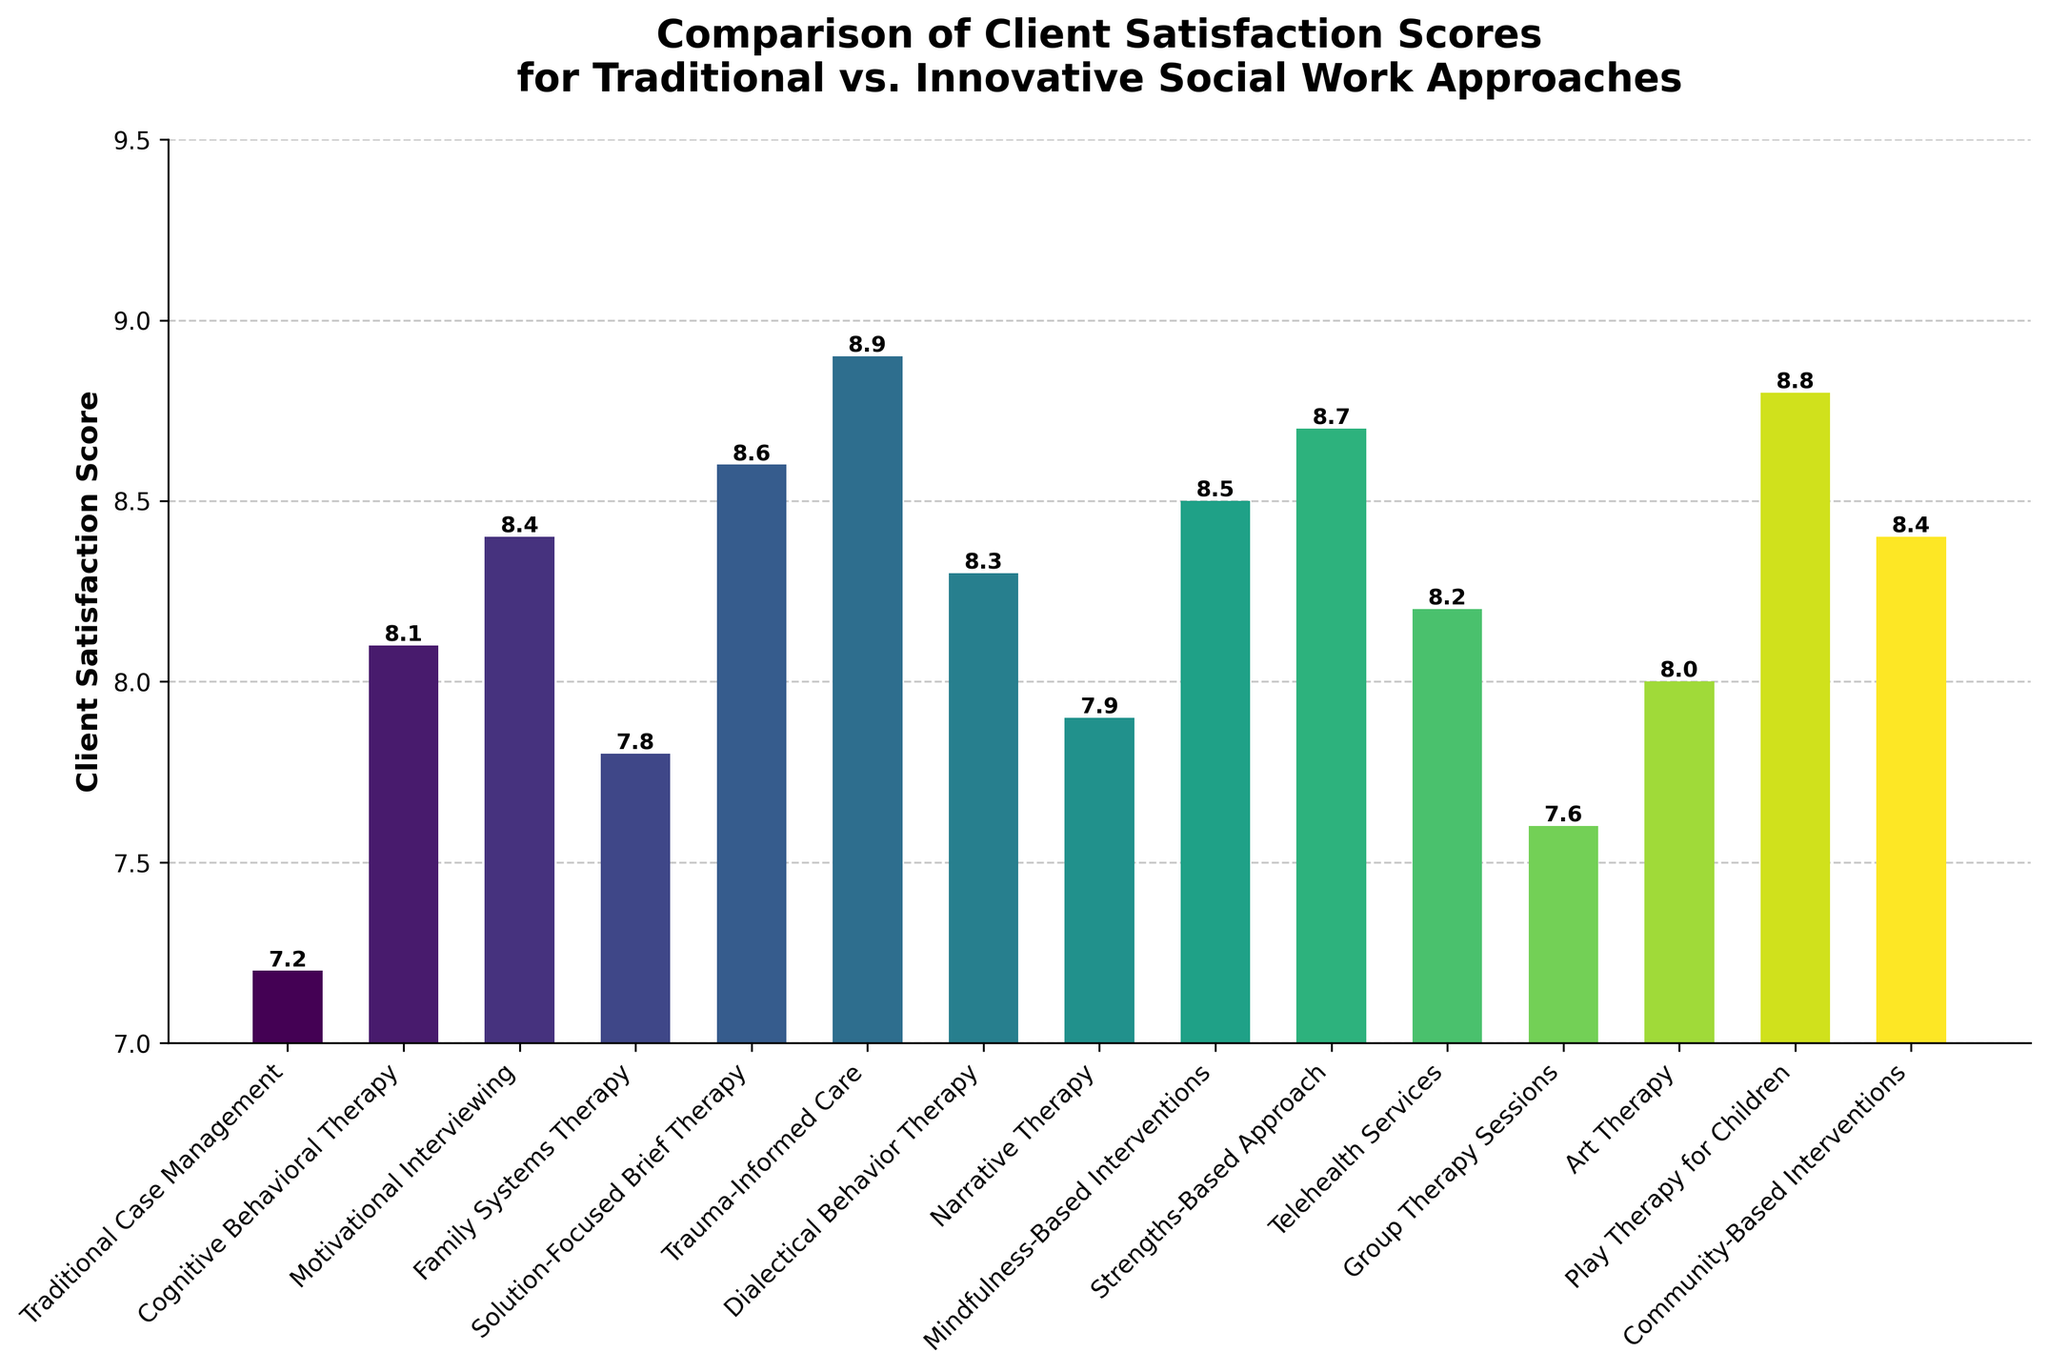Which approach has the highest client satisfaction score? By examining the heights of the bars, Trauma-Informed Care has the highest value, which is 8.9.
Answer: Trauma-Informed Care Which two approaches have the closest client satisfaction scores? Family Systems Therapy and Narrative Therapy have the closest scores, both slightly under 8. Family Systems Therapy is 7.8, and Narrative Therapy is 7.9, resulting in a difference of just 0.1.
Answer: Family Systems Therapy, Narrative Therapy What is the difference in client satisfaction scores between Solution-Focused Brief Therapy and Telehealth Services? Solution-Focused Brief Therapy has a score of 8.6, and Telehealth Services has a score of 8.2. The difference is calculated as 8.6 - 8.2 = 0.4.
Answer: 0.4 What is the average satisfaction score for traditional approaches if we consider "Traditional Case Management," "Group Therapy Sessions," and "Art Therapy" as traditional? "Traditional Case Management" has a score of 7.2, "Group Therapy Sessions" has 7.6, and "Art Therapy" has 8.0. The average is calculated as (7.2 + 7.6 + 8.0) / 3 = 22.8 / 3 ≈ 7.6.
Answer: 7.6 Which innovative approach has the lowest client satisfaction score? Among the innovative approaches, "Telehealth Services" has the lowest score, which is 8.2.
Answer: Telehealth Services How many approaches have scores above 8.5? The approaches with scores above 8.5 are Solution-Focused Brief Therapy (8.6), Trauma-Informed Care (8.9), Strengths-Based Approach (8.7), Mindfulness-Based Interventions (8.5), and Play Therapy for Children (8.8). The count is 5.
Answer: 5 What is the combined client satisfaction score of "Cognitive Behavioral Therapy" and "Dialectical Behavior Therapy"? Cognitive Behavioral Therapy has a score of 8.1, and Dialectical Behavior Therapy has 8.3. The combined score is 8.1 + 8.3 = 16.4.
Answer: 16.4 Is the client satisfaction score for "Motivational Interviewing" higher or lower than the average score of all approaches? First, find the average score of all approaches. The total sum of the scores is 121.4, and there are 15 approaches. So, the average score is 121.4 / 15 ≈ 8.1. Motivational Interviewing has a score of 8.4, which is higher than the average.
Answer: Higher Which approach's bar is colored closest to the mid-point of the colormap (roughly in the middle range of colors displayed)? Based on the viridis colormap, "Group Therapy Sessions" is towards the middle range with a score of 7.6.
Answer: Group Therapy Sessions What is the range of client satisfaction scores among all approaches? The highest score is for Trauma-Informed Care (8.9), and the lowest is Traditional Case Management (7.2). The range is 8.9 - 7.2 = 1.7.
Answer: 1.7 